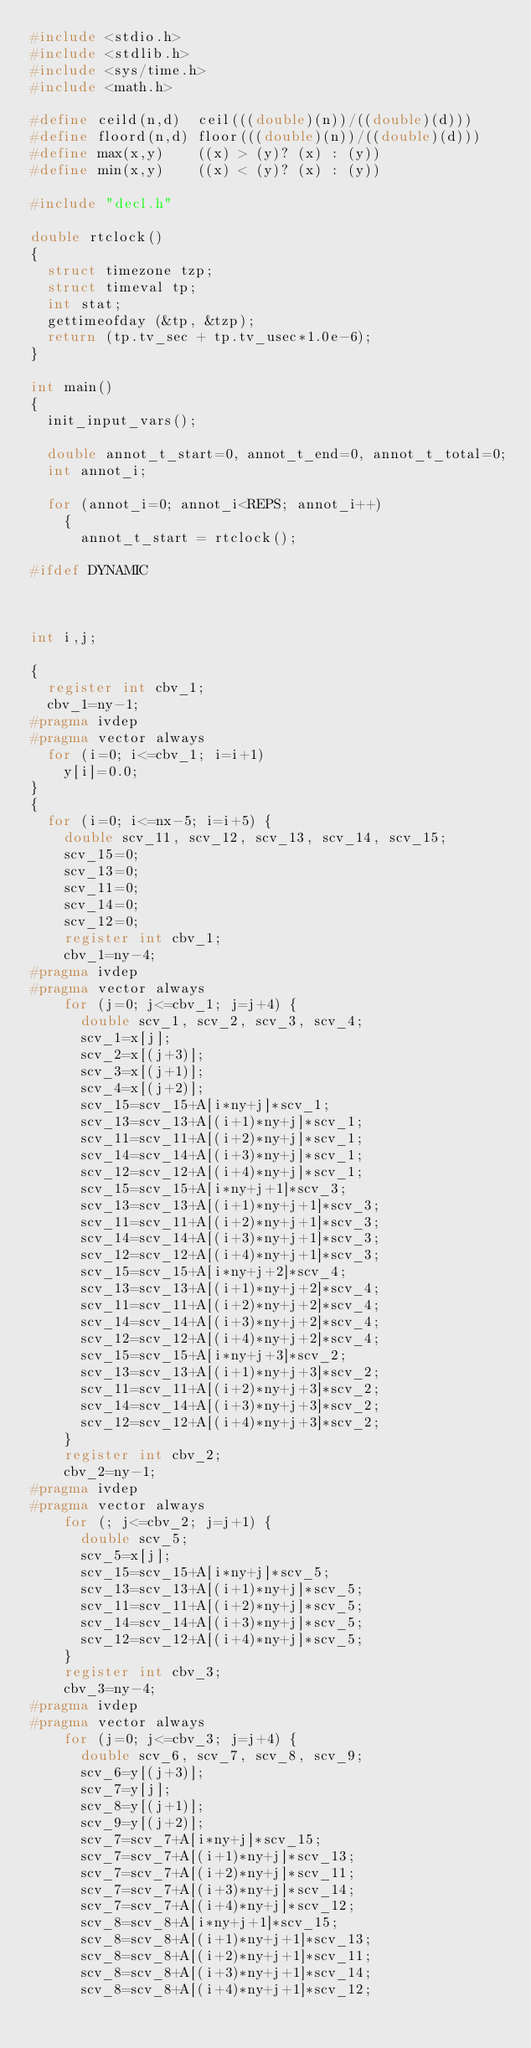Convert code to text. <code><loc_0><loc_0><loc_500><loc_500><_C_>#include <stdio.h>
#include <stdlib.h>
#include <sys/time.h>
#include <math.h>

#define ceild(n,d)  ceil(((double)(n))/((double)(d)))
#define floord(n,d) floor(((double)(n))/((double)(d)))
#define max(x,y)    ((x) > (y)? (x) : (y))
#define min(x,y)    ((x) < (y)? (x) : (y))

#include "decl.h"

double rtclock()
{
  struct timezone tzp;
  struct timeval tp;
  int stat;
  gettimeofday (&tp, &tzp);
  return (tp.tv_sec + tp.tv_usec*1.0e-6);
}

int main()
{
  init_input_vars();

  double annot_t_start=0, annot_t_end=0, annot_t_total=0;
  int annot_i;

  for (annot_i=0; annot_i<REPS; annot_i++)
    {
      annot_t_start = rtclock();

#ifdef DYNAMIC



int i,j;
  
{
  register int cbv_1;
  cbv_1=ny-1;
#pragma ivdep
#pragma vector always
  for (i=0; i<=cbv_1; i=i+1) 
    y[i]=0.0;
}
{
  for (i=0; i<=nx-5; i=i+5) {
    double scv_11, scv_12, scv_13, scv_14, scv_15;
    scv_15=0;
    scv_13=0;
    scv_11=0;
    scv_14=0;
    scv_12=0;
    register int cbv_1;
    cbv_1=ny-4;
#pragma ivdep
#pragma vector always
    for (j=0; j<=cbv_1; j=j+4) {
      double scv_1, scv_2, scv_3, scv_4;
      scv_1=x[j];
      scv_2=x[(j+3)];
      scv_3=x[(j+1)];
      scv_4=x[(j+2)];
      scv_15=scv_15+A[i*ny+j]*scv_1;
      scv_13=scv_13+A[(i+1)*ny+j]*scv_1;
      scv_11=scv_11+A[(i+2)*ny+j]*scv_1;
      scv_14=scv_14+A[(i+3)*ny+j]*scv_1;
      scv_12=scv_12+A[(i+4)*ny+j]*scv_1;
      scv_15=scv_15+A[i*ny+j+1]*scv_3;
      scv_13=scv_13+A[(i+1)*ny+j+1]*scv_3;
      scv_11=scv_11+A[(i+2)*ny+j+1]*scv_3;
      scv_14=scv_14+A[(i+3)*ny+j+1]*scv_3;
      scv_12=scv_12+A[(i+4)*ny+j+1]*scv_3;
      scv_15=scv_15+A[i*ny+j+2]*scv_4;
      scv_13=scv_13+A[(i+1)*ny+j+2]*scv_4;
      scv_11=scv_11+A[(i+2)*ny+j+2]*scv_4;
      scv_14=scv_14+A[(i+3)*ny+j+2]*scv_4;
      scv_12=scv_12+A[(i+4)*ny+j+2]*scv_4;
      scv_15=scv_15+A[i*ny+j+3]*scv_2;
      scv_13=scv_13+A[(i+1)*ny+j+3]*scv_2;
      scv_11=scv_11+A[(i+2)*ny+j+3]*scv_2;
      scv_14=scv_14+A[(i+3)*ny+j+3]*scv_2;
      scv_12=scv_12+A[(i+4)*ny+j+3]*scv_2;
    }
    register int cbv_2;
    cbv_2=ny-1;
#pragma ivdep
#pragma vector always
    for (; j<=cbv_2; j=j+1) {
      double scv_5;
      scv_5=x[j];
      scv_15=scv_15+A[i*ny+j]*scv_5;
      scv_13=scv_13+A[(i+1)*ny+j]*scv_5;
      scv_11=scv_11+A[(i+2)*ny+j]*scv_5;
      scv_14=scv_14+A[(i+3)*ny+j]*scv_5;
      scv_12=scv_12+A[(i+4)*ny+j]*scv_5;
    }
    register int cbv_3;
    cbv_3=ny-4;
#pragma ivdep
#pragma vector always
    for (j=0; j<=cbv_3; j=j+4) {
      double scv_6, scv_7, scv_8, scv_9;
      scv_6=y[(j+3)];
      scv_7=y[j];
      scv_8=y[(j+1)];
      scv_9=y[(j+2)];
      scv_7=scv_7+A[i*ny+j]*scv_15;
      scv_7=scv_7+A[(i+1)*ny+j]*scv_13;
      scv_7=scv_7+A[(i+2)*ny+j]*scv_11;
      scv_7=scv_7+A[(i+3)*ny+j]*scv_14;
      scv_7=scv_7+A[(i+4)*ny+j]*scv_12;
      scv_8=scv_8+A[i*ny+j+1]*scv_15;
      scv_8=scv_8+A[(i+1)*ny+j+1]*scv_13;
      scv_8=scv_8+A[(i+2)*ny+j+1]*scv_11;
      scv_8=scv_8+A[(i+3)*ny+j+1]*scv_14;
      scv_8=scv_8+A[(i+4)*ny+j+1]*scv_12;</code> 